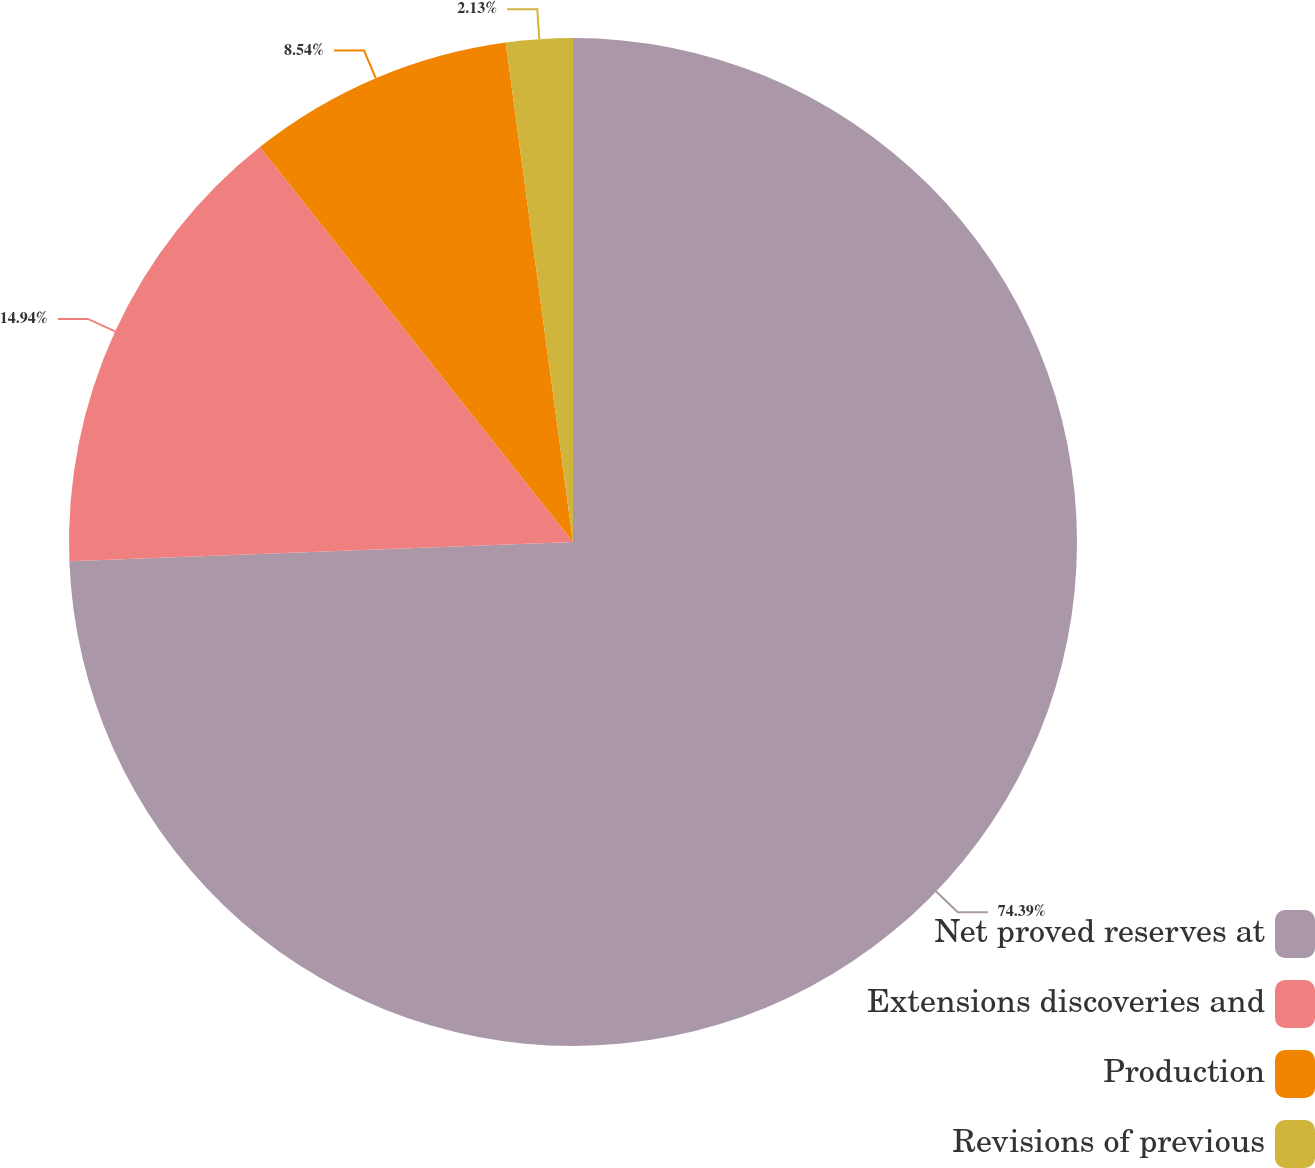Convert chart to OTSL. <chart><loc_0><loc_0><loc_500><loc_500><pie_chart><fcel>Net proved reserves at<fcel>Extensions discoveries and<fcel>Production<fcel>Revisions of previous<nl><fcel>74.39%<fcel>14.94%<fcel>8.54%<fcel>2.13%<nl></chart> 